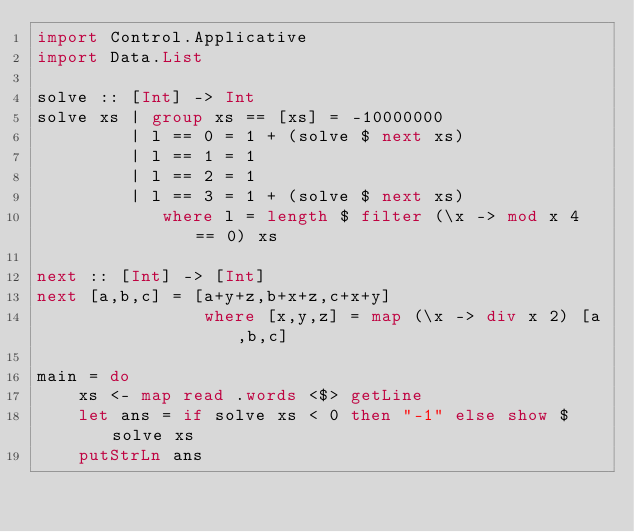<code> <loc_0><loc_0><loc_500><loc_500><_Haskell_>import Control.Applicative
import Data.List

solve :: [Int] -> Int
solve xs | group xs == [xs] = -10000000
         | l == 0 = 1 + (solve $ next xs)
         | l == 1 = 1
         | l == 2 = 1
         | l == 3 = 1 + (solve $ next xs)
            where l = length $ filter (\x -> mod x 4 == 0) xs

next :: [Int] -> [Int]
next [a,b,c] = [a+y+z,b+x+z,c+x+y]
                where [x,y,z] = map (\x -> div x 2) [a,b,c]

main = do
    xs <- map read .words <$> getLine
    let ans = if solve xs < 0 then "-1" else show $ solve xs
    putStrLn ans
</code> 